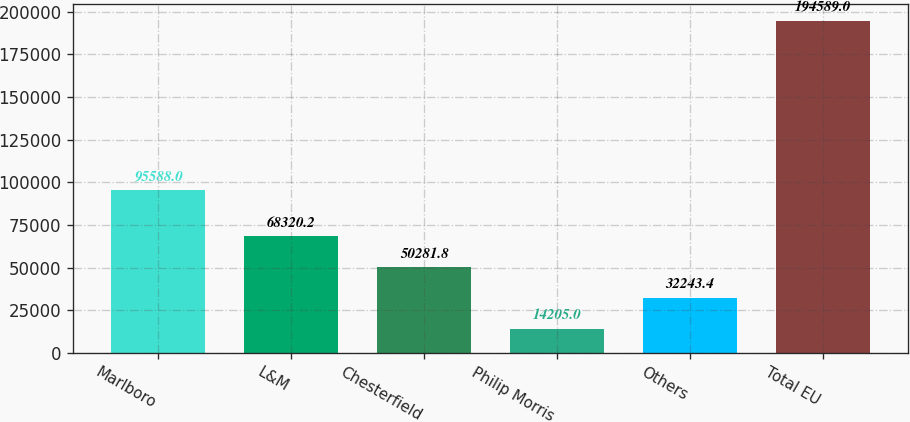Convert chart. <chart><loc_0><loc_0><loc_500><loc_500><bar_chart><fcel>Marlboro<fcel>L&M<fcel>Chesterfield<fcel>Philip Morris<fcel>Others<fcel>Total EU<nl><fcel>95588<fcel>68320.2<fcel>50281.8<fcel>14205<fcel>32243.4<fcel>194589<nl></chart> 